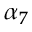<formula> <loc_0><loc_0><loc_500><loc_500>\alpha _ { 7 }</formula> 